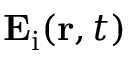<formula> <loc_0><loc_0><loc_500><loc_500>E _ { i } ( r , t )</formula> 